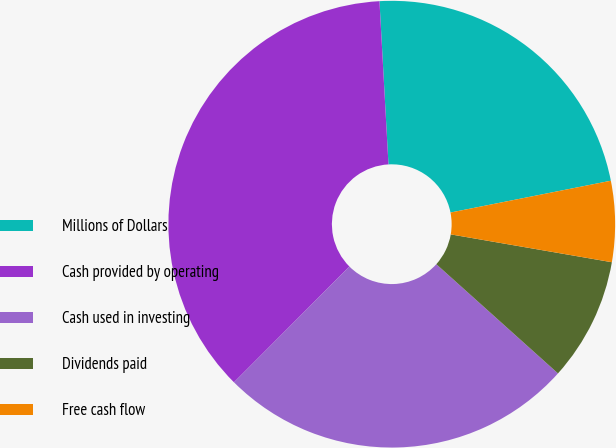Convert chart to OTSL. <chart><loc_0><loc_0><loc_500><loc_500><pie_chart><fcel>Millions of Dollars<fcel>Cash provided by operating<fcel>Cash used in investing<fcel>Dividends paid<fcel>Free cash flow<nl><fcel>22.76%<fcel>36.64%<fcel>25.84%<fcel>8.92%<fcel>5.84%<nl></chart> 